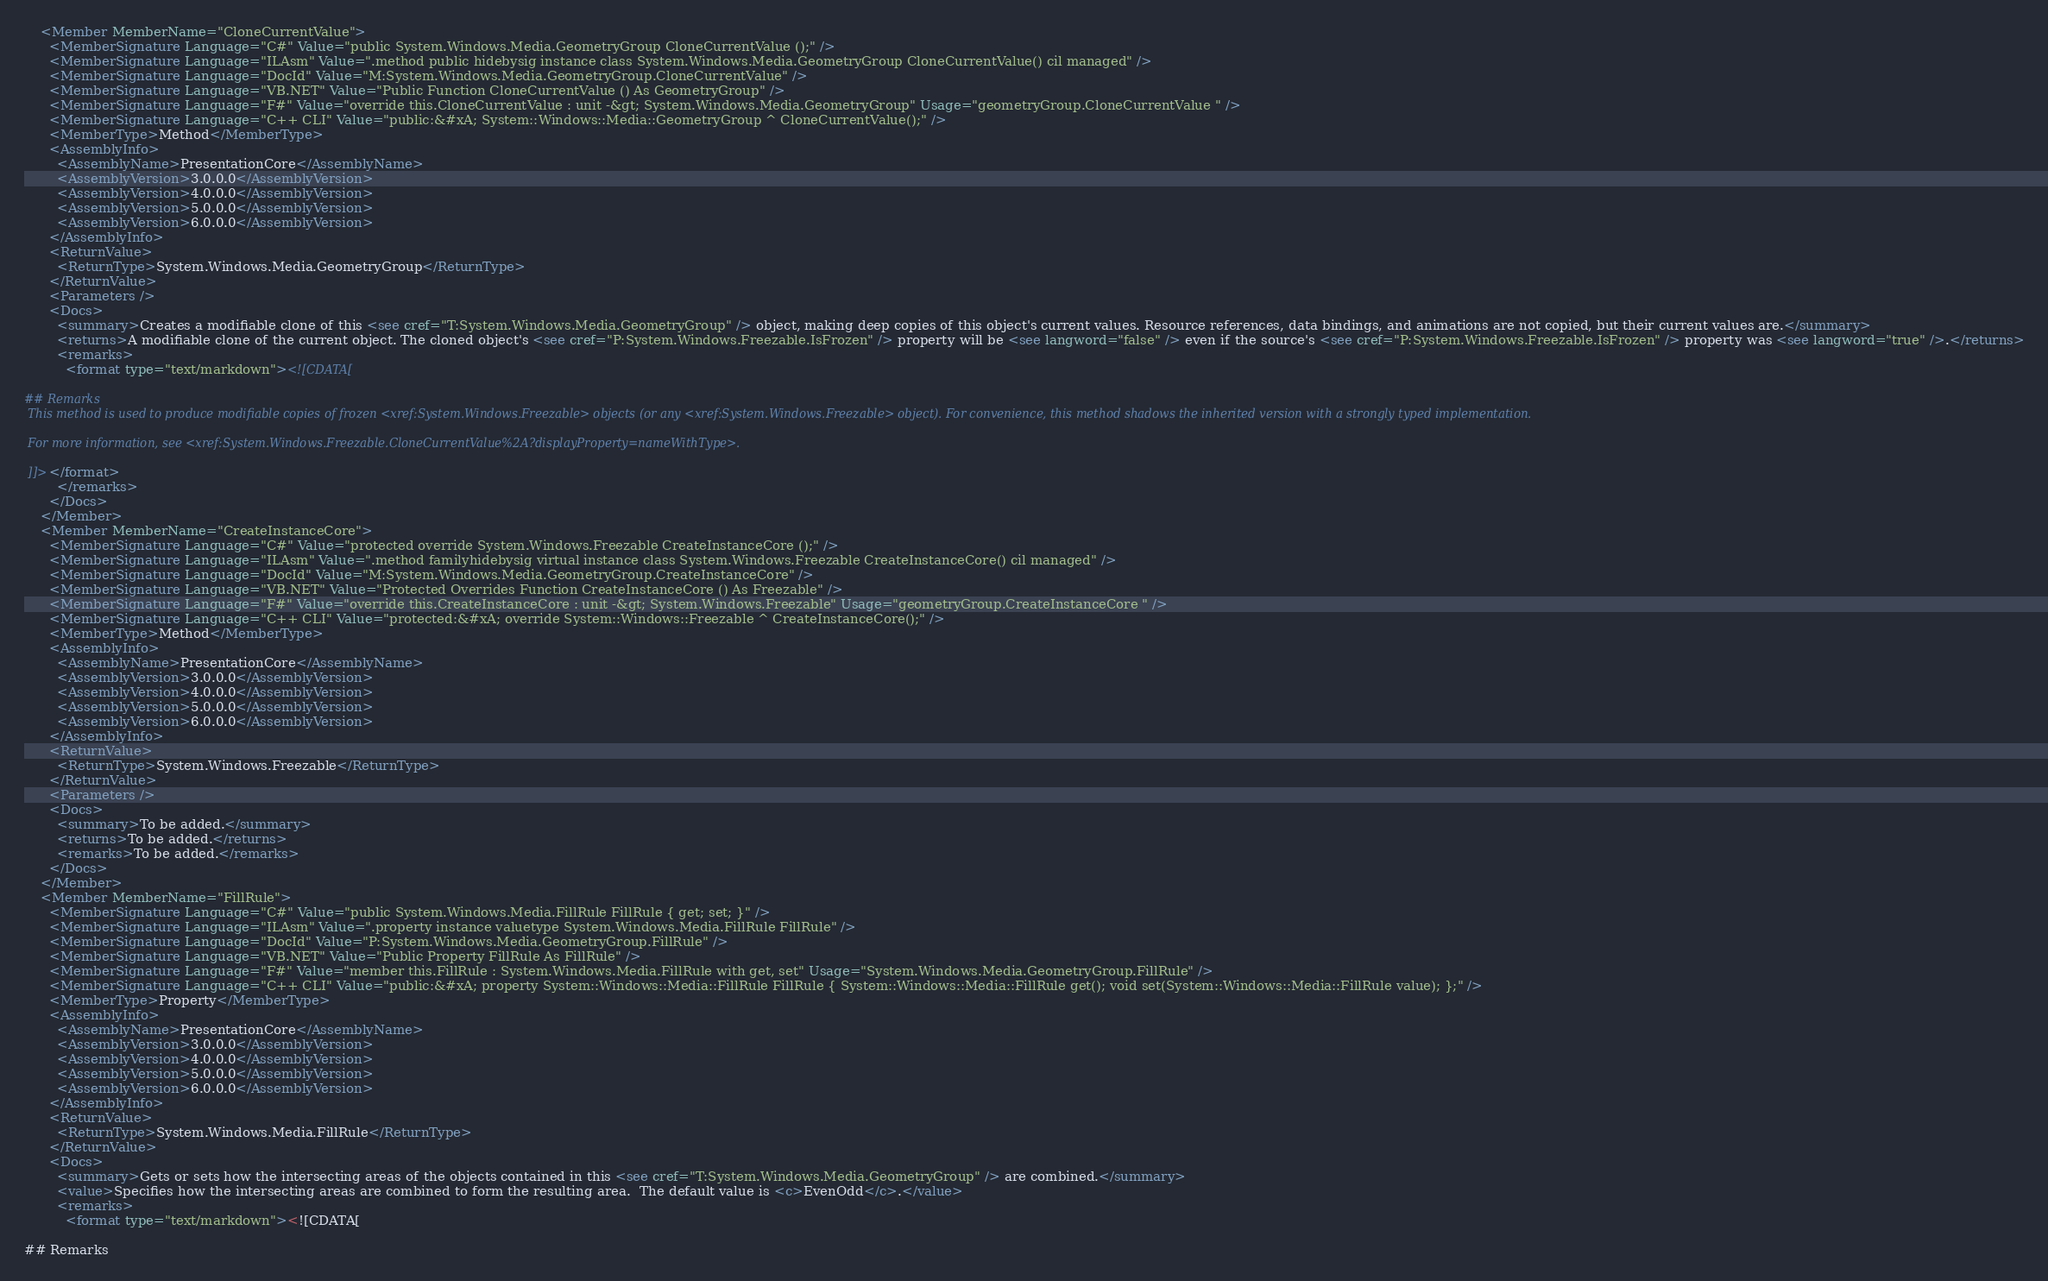<code> <loc_0><loc_0><loc_500><loc_500><_XML_>    <Member MemberName="CloneCurrentValue">
      <MemberSignature Language="C#" Value="public System.Windows.Media.GeometryGroup CloneCurrentValue ();" />
      <MemberSignature Language="ILAsm" Value=".method public hidebysig instance class System.Windows.Media.GeometryGroup CloneCurrentValue() cil managed" />
      <MemberSignature Language="DocId" Value="M:System.Windows.Media.GeometryGroup.CloneCurrentValue" />
      <MemberSignature Language="VB.NET" Value="Public Function CloneCurrentValue () As GeometryGroup" />
      <MemberSignature Language="F#" Value="override this.CloneCurrentValue : unit -&gt; System.Windows.Media.GeometryGroup" Usage="geometryGroup.CloneCurrentValue " />
      <MemberSignature Language="C++ CLI" Value="public:&#xA; System::Windows::Media::GeometryGroup ^ CloneCurrentValue();" />
      <MemberType>Method</MemberType>
      <AssemblyInfo>
        <AssemblyName>PresentationCore</AssemblyName>
        <AssemblyVersion>3.0.0.0</AssemblyVersion>
        <AssemblyVersion>4.0.0.0</AssemblyVersion>
        <AssemblyVersion>5.0.0.0</AssemblyVersion>
        <AssemblyVersion>6.0.0.0</AssemblyVersion>
      </AssemblyInfo>
      <ReturnValue>
        <ReturnType>System.Windows.Media.GeometryGroup</ReturnType>
      </ReturnValue>
      <Parameters />
      <Docs>
        <summary>Creates a modifiable clone of this <see cref="T:System.Windows.Media.GeometryGroup" /> object, making deep copies of this object's current values. Resource references, data bindings, and animations are not copied, but their current values are.</summary>
        <returns>A modifiable clone of the current object. The cloned object's <see cref="P:System.Windows.Freezable.IsFrozen" /> property will be <see langword="false" /> even if the source's <see cref="P:System.Windows.Freezable.IsFrozen" /> property was <see langword="true" />.</returns>
        <remarks>
          <format type="text/markdown"><![CDATA[  
  
## Remarks  
 This method is used to produce modifiable copies of frozen <xref:System.Windows.Freezable> objects (or any <xref:System.Windows.Freezable> object). For convenience, this method shadows the inherited version with a strongly typed implementation.  
  
 For more information, see <xref:System.Windows.Freezable.CloneCurrentValue%2A?displayProperty=nameWithType>.  
  
 ]]></format>
        </remarks>
      </Docs>
    </Member>
    <Member MemberName="CreateInstanceCore">
      <MemberSignature Language="C#" Value="protected override System.Windows.Freezable CreateInstanceCore ();" />
      <MemberSignature Language="ILAsm" Value=".method familyhidebysig virtual instance class System.Windows.Freezable CreateInstanceCore() cil managed" />
      <MemberSignature Language="DocId" Value="M:System.Windows.Media.GeometryGroup.CreateInstanceCore" />
      <MemberSignature Language="VB.NET" Value="Protected Overrides Function CreateInstanceCore () As Freezable" />
      <MemberSignature Language="F#" Value="override this.CreateInstanceCore : unit -&gt; System.Windows.Freezable" Usage="geometryGroup.CreateInstanceCore " />
      <MemberSignature Language="C++ CLI" Value="protected:&#xA; override System::Windows::Freezable ^ CreateInstanceCore();" />
      <MemberType>Method</MemberType>
      <AssemblyInfo>
        <AssemblyName>PresentationCore</AssemblyName>
        <AssemblyVersion>3.0.0.0</AssemblyVersion>
        <AssemblyVersion>4.0.0.0</AssemblyVersion>
        <AssemblyVersion>5.0.0.0</AssemblyVersion>
        <AssemblyVersion>6.0.0.0</AssemblyVersion>
      </AssemblyInfo>
      <ReturnValue>
        <ReturnType>System.Windows.Freezable</ReturnType>
      </ReturnValue>
      <Parameters />
      <Docs>
        <summary>To be added.</summary>
        <returns>To be added.</returns>
        <remarks>To be added.</remarks>
      </Docs>
    </Member>
    <Member MemberName="FillRule">
      <MemberSignature Language="C#" Value="public System.Windows.Media.FillRule FillRule { get; set; }" />
      <MemberSignature Language="ILAsm" Value=".property instance valuetype System.Windows.Media.FillRule FillRule" />
      <MemberSignature Language="DocId" Value="P:System.Windows.Media.GeometryGroup.FillRule" />
      <MemberSignature Language="VB.NET" Value="Public Property FillRule As FillRule" />
      <MemberSignature Language="F#" Value="member this.FillRule : System.Windows.Media.FillRule with get, set" Usage="System.Windows.Media.GeometryGroup.FillRule" />
      <MemberSignature Language="C++ CLI" Value="public:&#xA; property System::Windows::Media::FillRule FillRule { System::Windows::Media::FillRule get(); void set(System::Windows::Media::FillRule value); };" />
      <MemberType>Property</MemberType>
      <AssemblyInfo>
        <AssemblyName>PresentationCore</AssemblyName>
        <AssemblyVersion>3.0.0.0</AssemblyVersion>
        <AssemblyVersion>4.0.0.0</AssemblyVersion>
        <AssemblyVersion>5.0.0.0</AssemblyVersion>
        <AssemblyVersion>6.0.0.0</AssemblyVersion>
      </AssemblyInfo>
      <ReturnValue>
        <ReturnType>System.Windows.Media.FillRule</ReturnType>
      </ReturnValue>
      <Docs>
        <summary>Gets or sets how the intersecting areas of the objects contained in this <see cref="T:System.Windows.Media.GeometryGroup" /> are combined.</summary>
        <value>Specifies how the intersecting areas are combined to form the resulting area.  The default value is <c>EvenOdd</c>.</value>
        <remarks>
          <format type="text/markdown"><![CDATA[  
  
## Remarks  </code> 